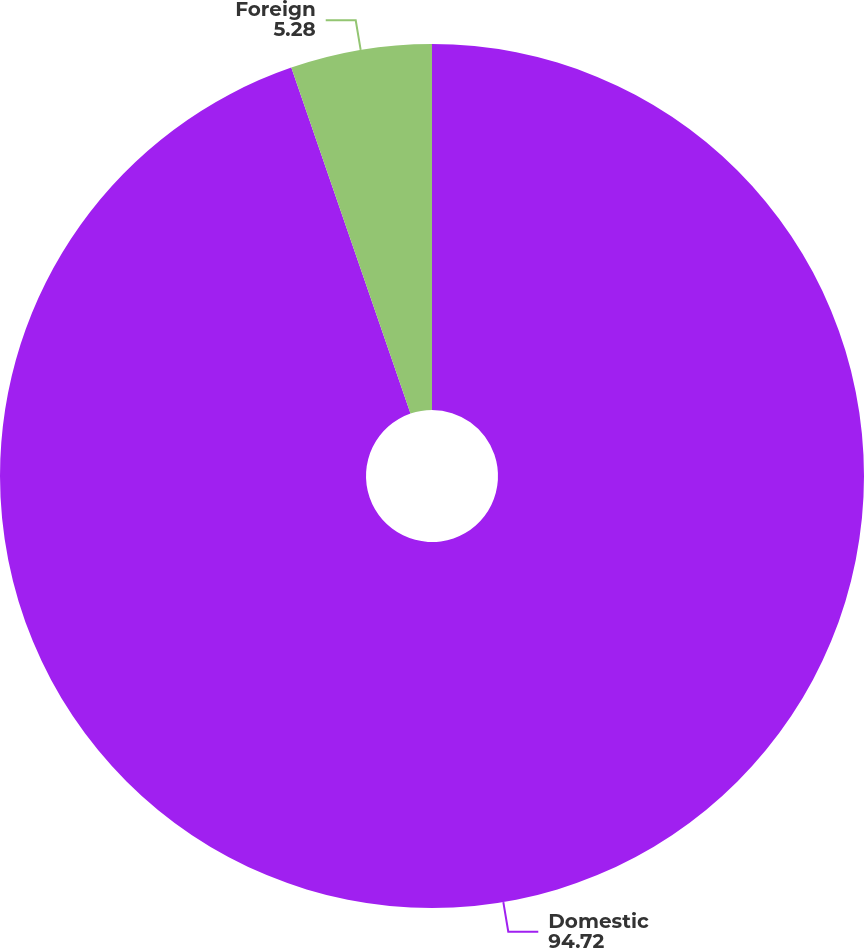<chart> <loc_0><loc_0><loc_500><loc_500><pie_chart><fcel>Domestic<fcel>Foreign<nl><fcel>94.72%<fcel>5.28%<nl></chart> 